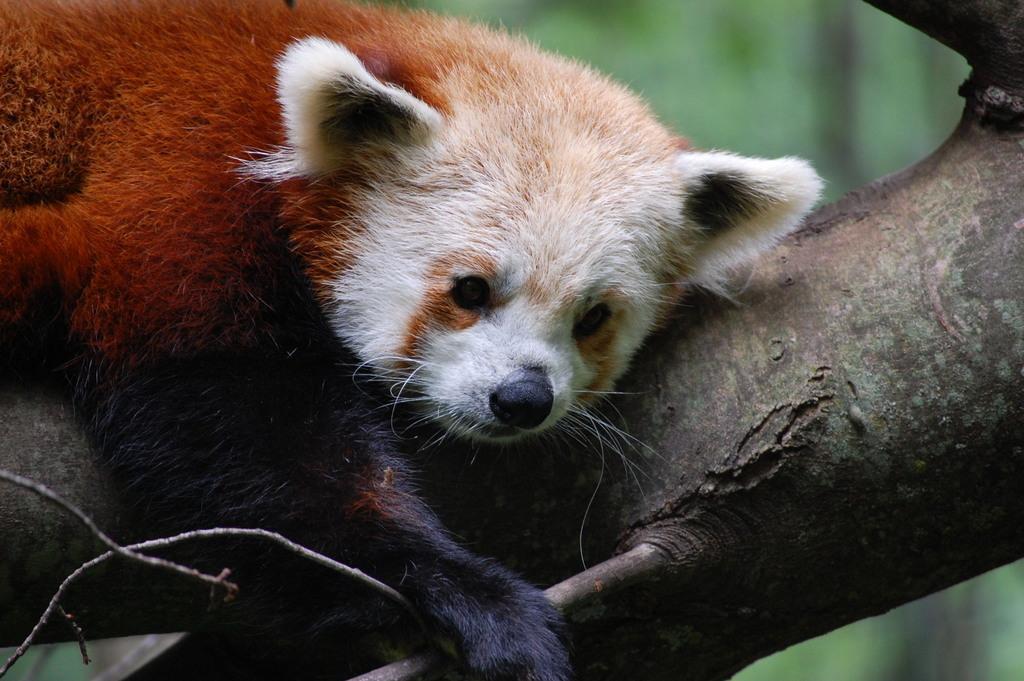Can you describe this image briefly? In the image in the center,we can see one tree. On the tree,we can see one panda,which is in red and white color. 